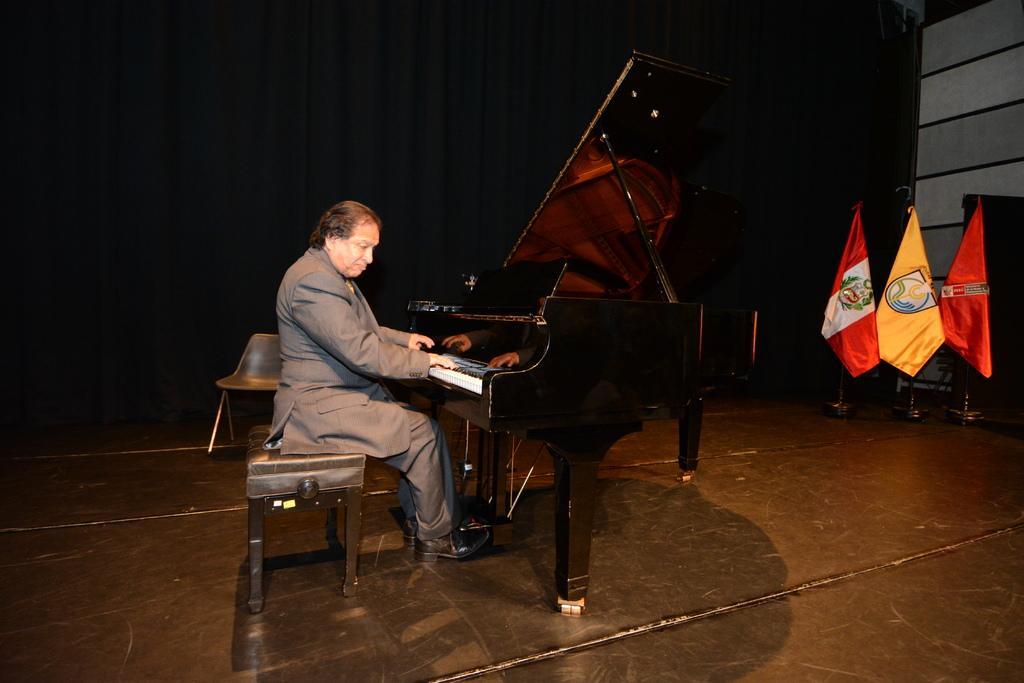Describe this image in one or two sentences. In this picture there is a man playing a piano in the center of the stage. Towards the right there are three flags which are in red and yellow. In the background there is a curtain. The man is wearing a grey blazer and grey trousers. 